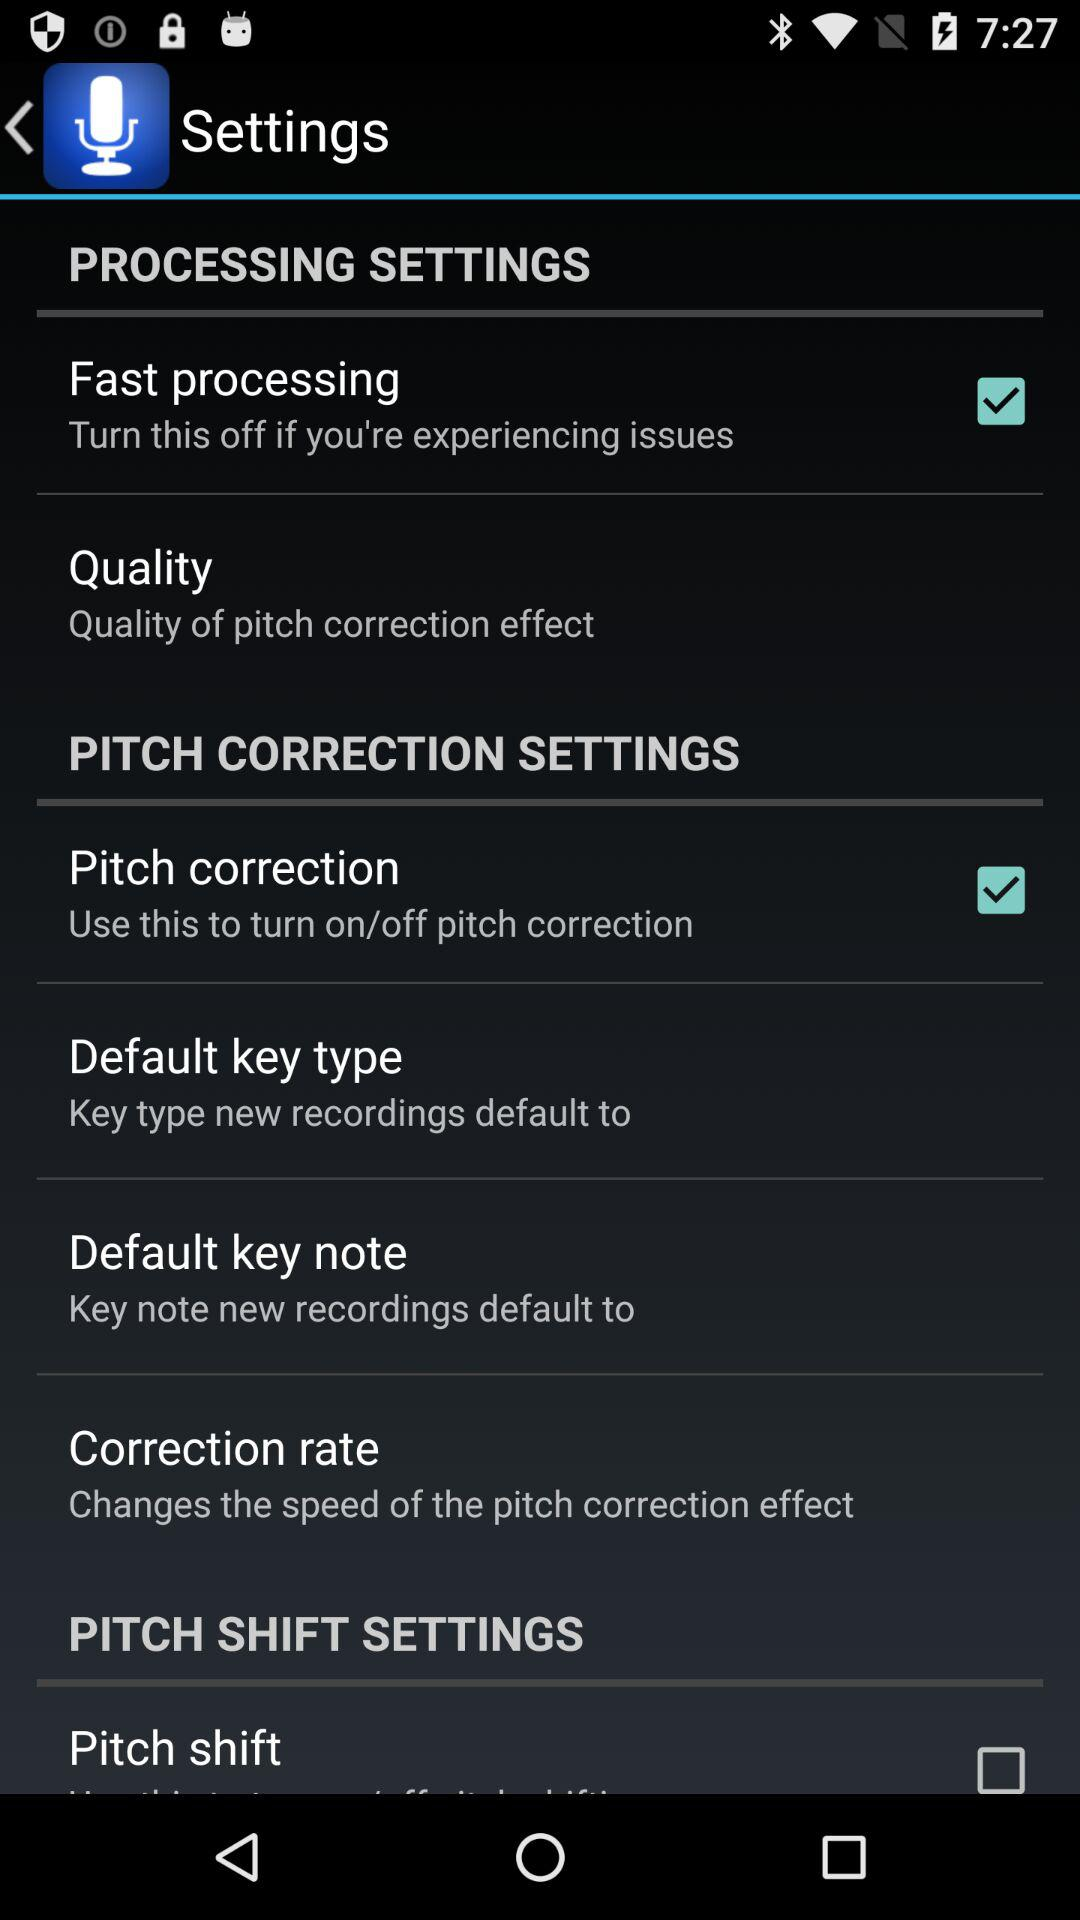Is "Pitch correction" on or off? "Pitch correction" is on. 